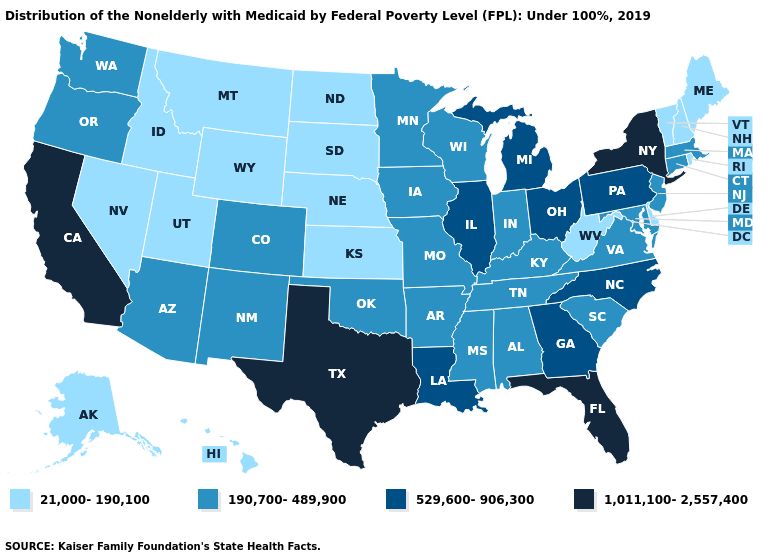Which states have the highest value in the USA?
Keep it brief. California, Florida, New York, Texas. Does Texas have the highest value in the USA?
Write a very short answer. Yes. Among the states that border Louisiana , which have the lowest value?
Concise answer only. Arkansas, Mississippi. Name the states that have a value in the range 190,700-489,900?
Keep it brief. Alabama, Arizona, Arkansas, Colorado, Connecticut, Indiana, Iowa, Kentucky, Maryland, Massachusetts, Minnesota, Mississippi, Missouri, New Jersey, New Mexico, Oklahoma, Oregon, South Carolina, Tennessee, Virginia, Washington, Wisconsin. Does Nevada have the lowest value in the USA?
Be succinct. Yes. What is the highest value in the South ?
Concise answer only. 1,011,100-2,557,400. Name the states that have a value in the range 21,000-190,100?
Give a very brief answer. Alaska, Delaware, Hawaii, Idaho, Kansas, Maine, Montana, Nebraska, Nevada, New Hampshire, North Dakota, Rhode Island, South Dakota, Utah, Vermont, West Virginia, Wyoming. Does New Jersey have the lowest value in the Northeast?
Answer briefly. No. Which states have the lowest value in the Northeast?
Short answer required. Maine, New Hampshire, Rhode Island, Vermont. Does California have the highest value in the USA?
Answer briefly. Yes. Name the states that have a value in the range 529,600-906,300?
Keep it brief. Georgia, Illinois, Louisiana, Michigan, North Carolina, Ohio, Pennsylvania. Does the first symbol in the legend represent the smallest category?
Concise answer only. Yes. Which states have the lowest value in the Northeast?
Answer briefly. Maine, New Hampshire, Rhode Island, Vermont. Among the states that border Kansas , which have the highest value?
Write a very short answer. Colorado, Missouri, Oklahoma. Name the states that have a value in the range 1,011,100-2,557,400?
Short answer required. California, Florida, New York, Texas. 